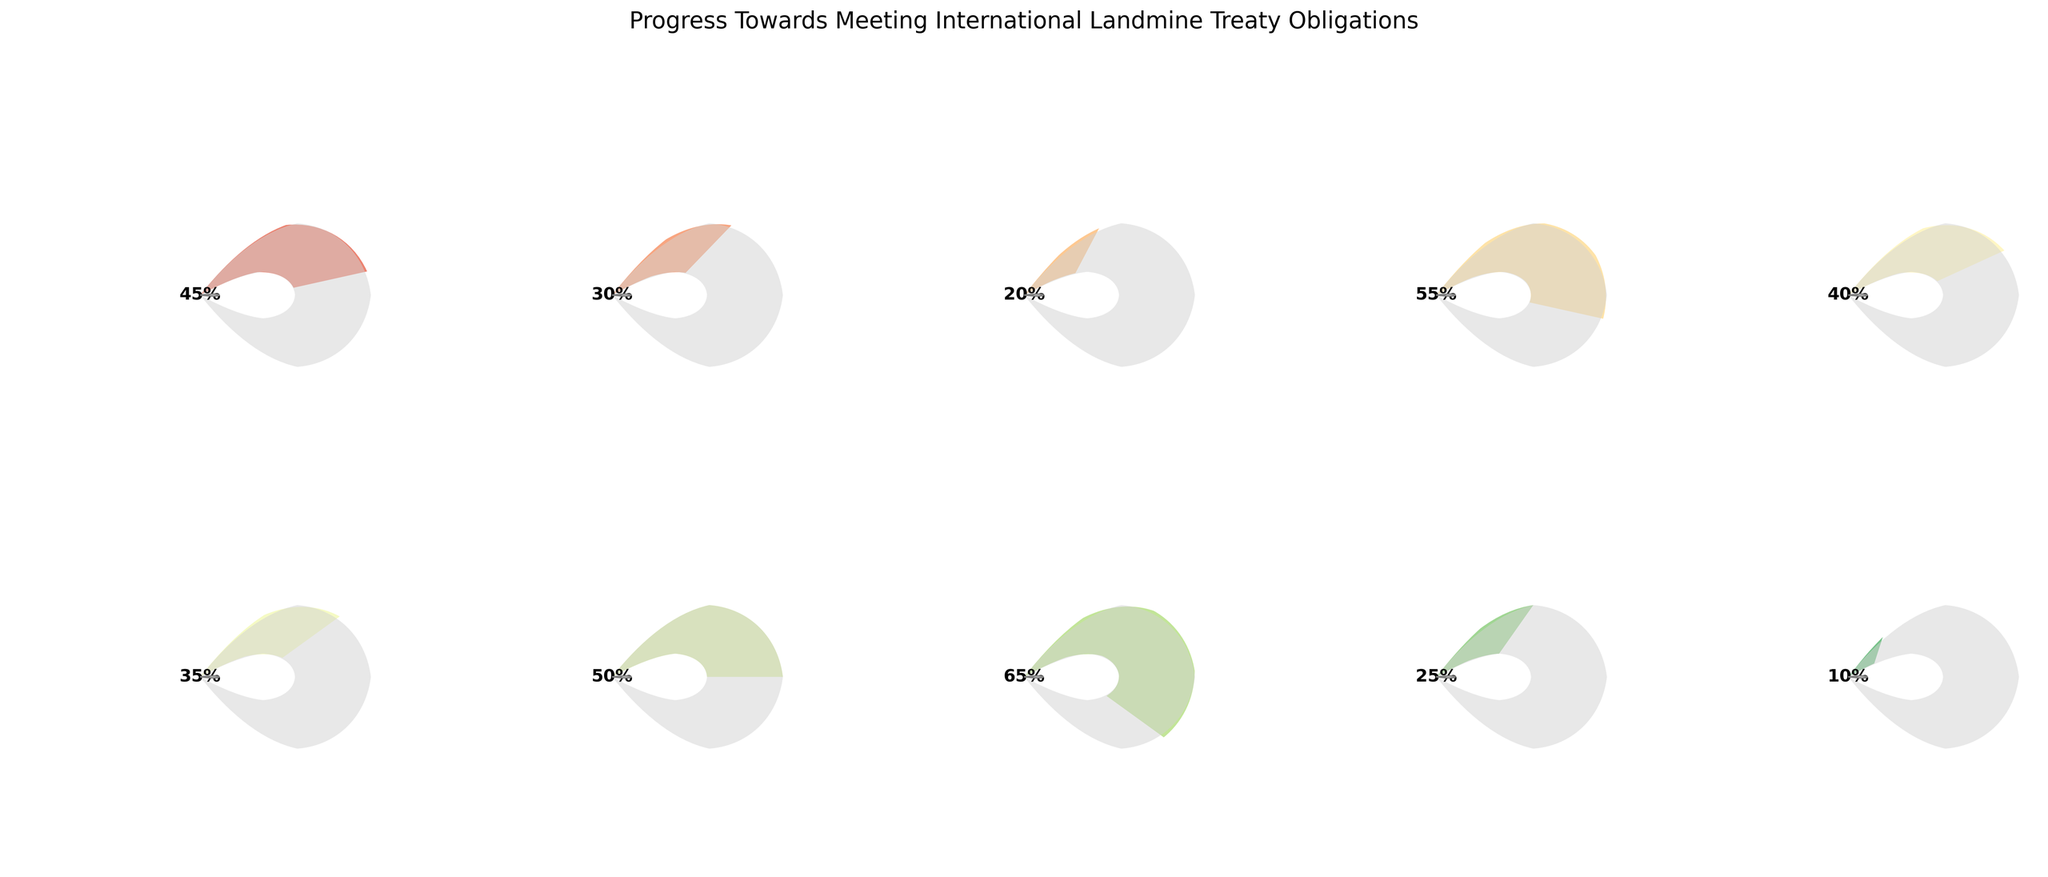What's the title of the figure? The title of the figure is displayed at the top and reads "Progress Towards Meeting International Landmine Treaty Obligations".
Answer: Progress Towards Meeting International Landmine Treaty Obligations Which country shows the highest progress towards meeting international landmine treaty obligations? By examining the gauge charts, the country with the highest progress rate is South Korea with 65%.
Answer: South Korea What is the average progress of the listed countries towards the treaty obligations? To find the average progress, sum all the progress percentages and divide by the number of countries: (45 + 30 + 20 + 55 + 40 + 35 + 50 + 65 + 25 + 10) / 10 = 37.5%.
Answer: 37.5% Which countries have a progress rate greater than 50%? The countries with more than 50% progress are indicated by the values on the gauge. These countries are India (55%) and South Korea (65%).
Answer: India, South Korea Which country has a lower progress rate: Russia or Iran? Comparing the progress rates from the gauges, Russia has a progress of 30% whereas Iran has 25%. Thus, Iran has a lower progress rate.
Answer: Iran Among the listed countries, how many have a progress rate below 40%? Count the countries with progress rates below 40%: Russia (30%), China (20%), Pakistan (40%, which is exactly 40% and not below), Israel (35%), Iran (25%), and North Korea (10%). This is a total of 5 countries.
Answer: 5 What's the combined progress rate of the United States and Egypt? Add the progress rates of the United States and Egypt: 45% (United States) + 50% (Egypt) = 95%.
Answer: 95% Which countries have a progress rate between 30% and 50% inclusive? The countries within the 30%-50% range as shown on the gauges are United States (45%), Russia (30%, included as 'inclusive'), Israel (35%), and Pakistan (40%).
Answer: United States, Russia, Israel, Pakistan What is the difference in progress rates between China and North Korea? Calculate the difference by subtracting North Korea's progress from China's: 20% (China) - 10% (North Korea) = 10%.
Answer: 10% Which country shows the smallest progress towards the treaty obligations? The smallest progress rate visible on the gauge charts is from North Korea, with a progress rate of 10%.
Answer: North Korea 